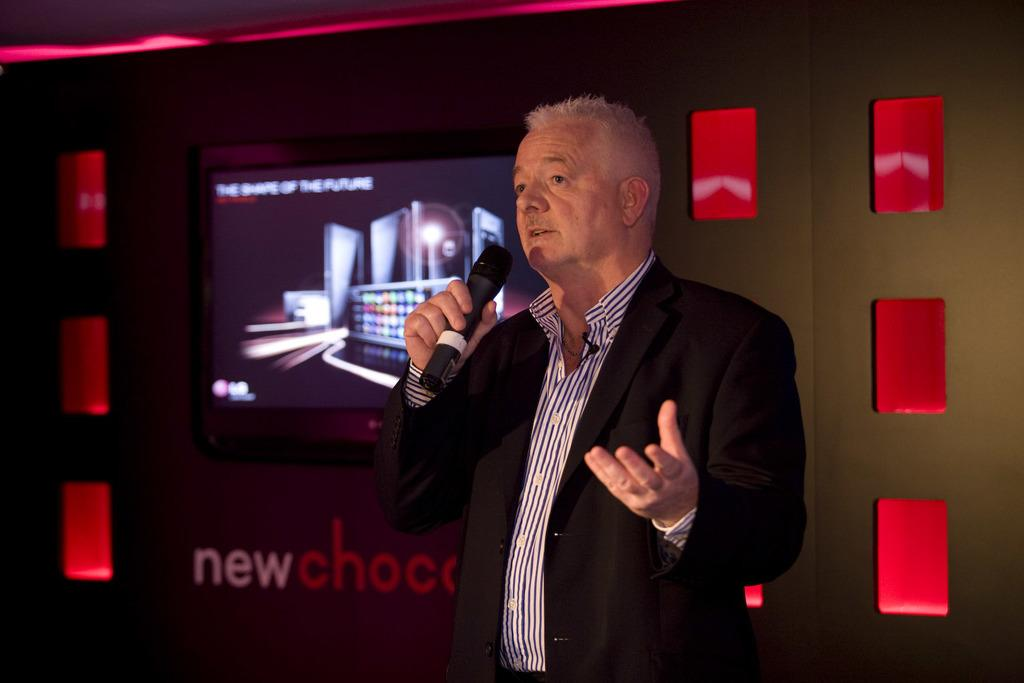What is the main subject of the image? The main subject of the image is a man. What is the man holding in his hand? The man is holding a microphone in his hand. What type of plantation can be seen in the background of the image? There is no plantation present in the image; it only features a man holding a microphone. 